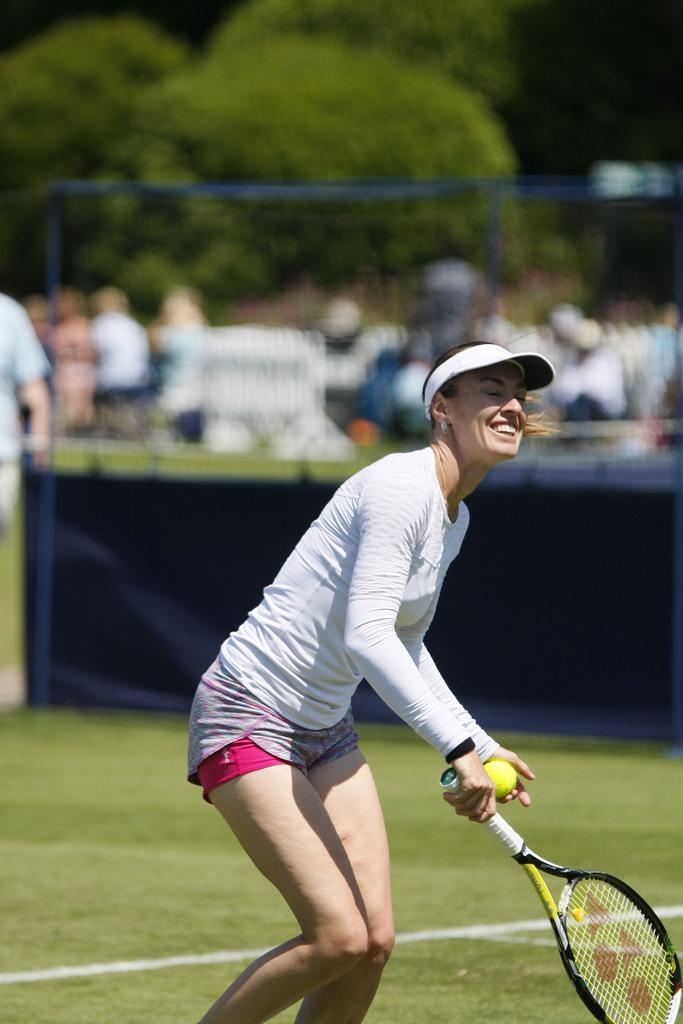Who is present in the image? There is a woman in the image. What is the woman doing in the image? The woman is standing and smiling. What objects is the woman holding in the image? The woman is holding a tennis ball and a tennis racket. What can be seen in the background of the image? There is a crowd and trees in the background of the image. What type of patch is being sewn onto the woman's shirt in the image? There is no patch visible on the woman's shirt in the image. What brand of soap is being advertised by the woman in the image? The woman is not advertising any soap in the image; she is holding a tennis ball and a tennis racket. 